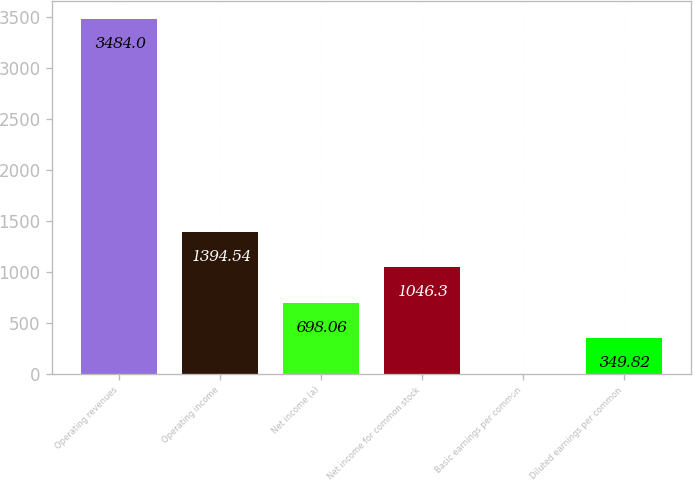Convert chart to OTSL. <chart><loc_0><loc_0><loc_500><loc_500><bar_chart><fcel>Operating revenues<fcel>Operating income<fcel>Net income (a)<fcel>Net income for common stock<fcel>Basic earnings per common<fcel>Diluted earnings per common<nl><fcel>3484<fcel>1394.54<fcel>698.06<fcel>1046.3<fcel>1.58<fcel>349.82<nl></chart> 